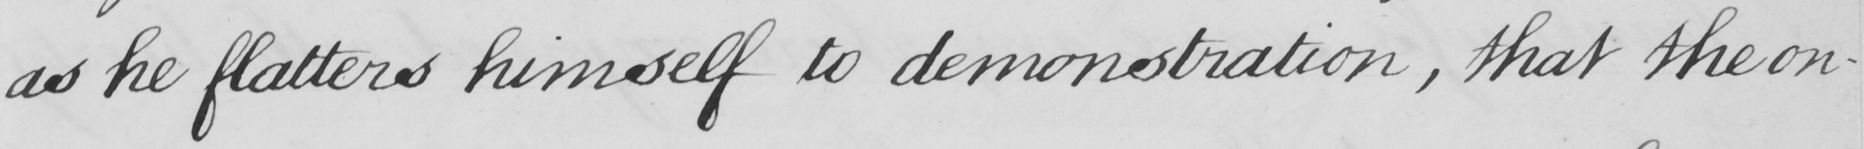What does this handwritten line say? as he flatters himself to demonstration , that the on- 